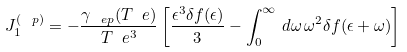<formula> <loc_0><loc_0><loc_500><loc_500>J _ { 1 } ^ { ( \ p ) } = - \frac { \gamma _ { \ e p } ( T _ { \ } e ) } { T _ { \ } e ^ { 3 } } \left [ \frac { \epsilon ^ { 3 } \delta f ( \epsilon ) } { 3 } - \int _ { 0 } ^ { \infty } \, d \omega \, \omega ^ { 2 } \delta f ( \epsilon + \omega ) \right ]</formula> 